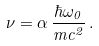Convert formula to latex. <formula><loc_0><loc_0><loc_500><loc_500>\nu = \alpha \, \frac { \hbar { \omega } _ { 0 } } { m c ^ { 2 } } \, .</formula> 